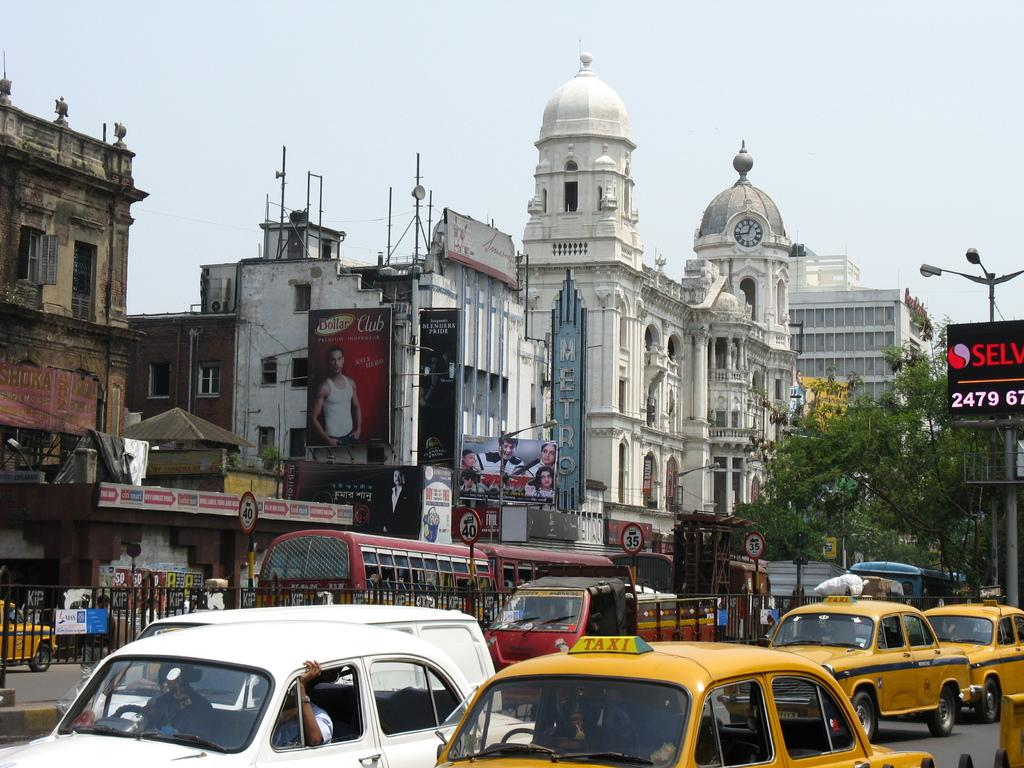<image>
Share a concise interpretation of the image provided. three yellow taxi cabs are driving down the road. 